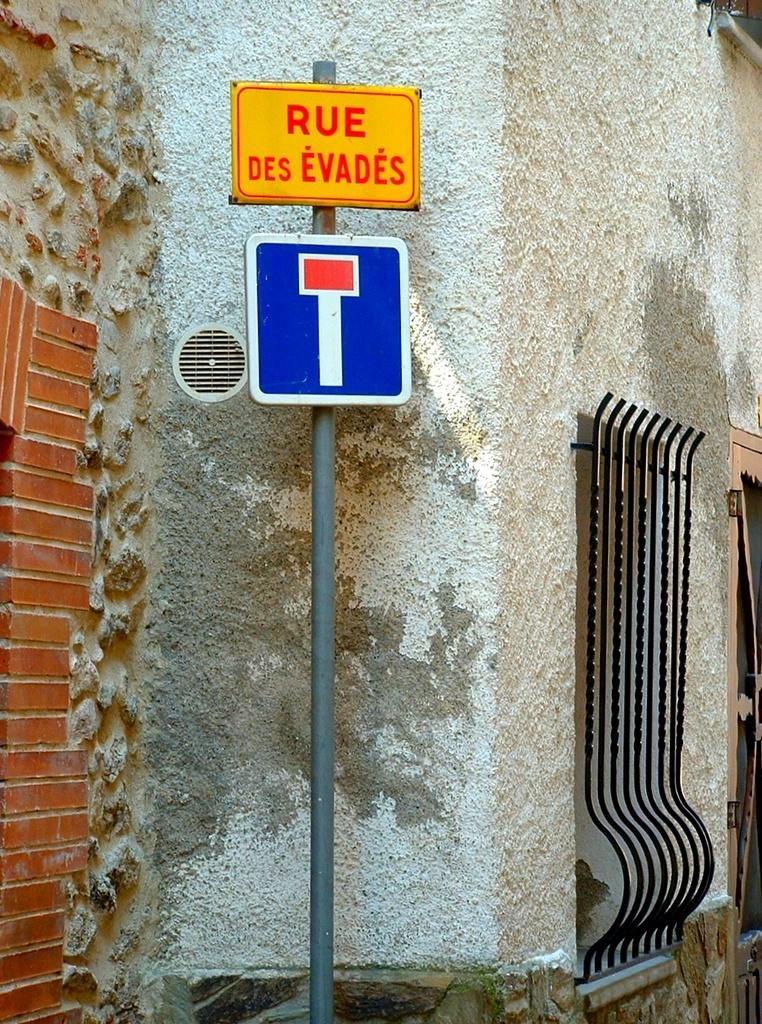<image>
Share a concise interpretation of the image provided. A sign that says, 'Rue Des Evades', is on a pole next to a wall. 